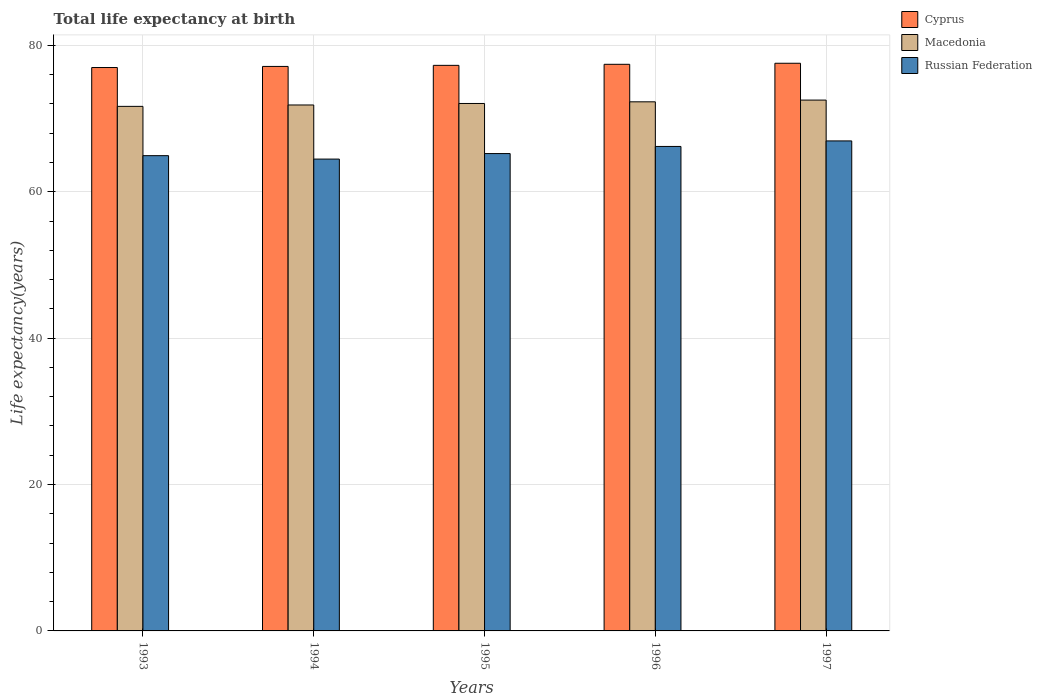How many different coloured bars are there?
Offer a very short reply. 3. Are the number of bars per tick equal to the number of legend labels?
Your answer should be very brief. Yes. Are the number of bars on each tick of the X-axis equal?
Offer a very short reply. Yes. What is the life expectancy at birth in in Russian Federation in 1996?
Make the answer very short. 66.19. Across all years, what is the maximum life expectancy at birth in in Russian Federation?
Give a very brief answer. 66.95. Across all years, what is the minimum life expectancy at birth in in Macedonia?
Give a very brief answer. 71.67. In which year was the life expectancy at birth in in Cyprus minimum?
Offer a terse response. 1993. What is the total life expectancy at birth in in Russian Federation in the graph?
Your answer should be compact. 327.77. What is the difference between the life expectancy at birth in in Russian Federation in 1994 and that in 1997?
Keep it short and to the point. -2.48. What is the difference between the life expectancy at birth in in Cyprus in 1993 and the life expectancy at birth in in Russian Federation in 1994?
Keep it short and to the point. 12.51. What is the average life expectancy at birth in in Macedonia per year?
Your answer should be compact. 72.08. In the year 1994, what is the difference between the life expectancy at birth in in Macedonia and life expectancy at birth in in Russian Federation?
Your response must be concise. 7.39. In how many years, is the life expectancy at birth in in Cyprus greater than 40 years?
Provide a short and direct response. 5. What is the ratio of the life expectancy at birth in in Macedonia in 1996 to that in 1997?
Your response must be concise. 1. Is the life expectancy at birth in in Russian Federation in 1993 less than that in 1997?
Provide a succinct answer. Yes. What is the difference between the highest and the second highest life expectancy at birth in in Russian Federation?
Keep it short and to the point. 0.76. What is the difference between the highest and the lowest life expectancy at birth in in Macedonia?
Offer a very short reply. 0.86. In how many years, is the life expectancy at birth in in Macedonia greater than the average life expectancy at birth in in Macedonia taken over all years?
Provide a succinct answer. 2. Is the sum of the life expectancy at birth in in Macedonia in 1995 and 1997 greater than the maximum life expectancy at birth in in Cyprus across all years?
Give a very brief answer. Yes. What does the 3rd bar from the left in 1993 represents?
Provide a short and direct response. Russian Federation. What does the 2nd bar from the right in 1997 represents?
Provide a short and direct response. Macedonia. Is it the case that in every year, the sum of the life expectancy at birth in in Cyprus and life expectancy at birth in in Russian Federation is greater than the life expectancy at birth in in Macedonia?
Ensure brevity in your answer.  Yes. How many bars are there?
Your answer should be compact. 15. Are all the bars in the graph horizontal?
Offer a very short reply. No. How many years are there in the graph?
Provide a succinct answer. 5. What is the difference between two consecutive major ticks on the Y-axis?
Offer a terse response. 20. Are the values on the major ticks of Y-axis written in scientific E-notation?
Offer a terse response. No. How are the legend labels stacked?
Provide a succinct answer. Vertical. What is the title of the graph?
Provide a short and direct response. Total life expectancy at birth. What is the label or title of the Y-axis?
Provide a succinct answer. Life expectancy(years). What is the Life expectancy(years) in Cyprus in 1993?
Offer a very short reply. 76.98. What is the Life expectancy(years) of Macedonia in 1993?
Provide a short and direct response. 71.67. What is the Life expectancy(years) of Russian Federation in 1993?
Provide a succinct answer. 64.94. What is the Life expectancy(years) of Cyprus in 1994?
Your answer should be compact. 77.13. What is the Life expectancy(years) of Macedonia in 1994?
Give a very brief answer. 71.86. What is the Life expectancy(years) of Russian Federation in 1994?
Your response must be concise. 64.47. What is the Life expectancy(years) in Cyprus in 1995?
Offer a very short reply. 77.27. What is the Life expectancy(years) of Macedonia in 1995?
Offer a very short reply. 72.07. What is the Life expectancy(years) in Russian Federation in 1995?
Make the answer very short. 65.22. What is the Life expectancy(years) of Cyprus in 1996?
Provide a short and direct response. 77.42. What is the Life expectancy(years) of Macedonia in 1996?
Give a very brief answer. 72.29. What is the Life expectancy(years) in Russian Federation in 1996?
Ensure brevity in your answer.  66.19. What is the Life expectancy(years) in Cyprus in 1997?
Offer a very short reply. 77.56. What is the Life expectancy(years) in Macedonia in 1997?
Your response must be concise. 72.53. What is the Life expectancy(years) in Russian Federation in 1997?
Your response must be concise. 66.95. Across all years, what is the maximum Life expectancy(years) in Cyprus?
Provide a short and direct response. 77.56. Across all years, what is the maximum Life expectancy(years) of Macedonia?
Offer a terse response. 72.53. Across all years, what is the maximum Life expectancy(years) of Russian Federation?
Make the answer very short. 66.95. Across all years, what is the minimum Life expectancy(years) in Cyprus?
Make the answer very short. 76.98. Across all years, what is the minimum Life expectancy(years) in Macedonia?
Offer a very short reply. 71.67. Across all years, what is the minimum Life expectancy(years) in Russian Federation?
Keep it short and to the point. 64.47. What is the total Life expectancy(years) in Cyprus in the graph?
Your answer should be compact. 386.36. What is the total Life expectancy(years) in Macedonia in the graph?
Your answer should be compact. 360.42. What is the total Life expectancy(years) in Russian Federation in the graph?
Ensure brevity in your answer.  327.77. What is the difference between the Life expectancy(years) of Cyprus in 1993 and that in 1994?
Keep it short and to the point. -0.15. What is the difference between the Life expectancy(years) of Macedonia in 1993 and that in 1994?
Offer a terse response. -0.19. What is the difference between the Life expectancy(years) of Russian Federation in 1993 and that in 1994?
Give a very brief answer. 0.47. What is the difference between the Life expectancy(years) of Cyprus in 1993 and that in 1995?
Offer a very short reply. -0.3. What is the difference between the Life expectancy(years) in Macedonia in 1993 and that in 1995?
Give a very brief answer. -0.4. What is the difference between the Life expectancy(years) in Russian Federation in 1993 and that in 1995?
Your answer should be very brief. -0.29. What is the difference between the Life expectancy(years) of Cyprus in 1993 and that in 1996?
Provide a short and direct response. -0.44. What is the difference between the Life expectancy(years) in Macedonia in 1993 and that in 1996?
Make the answer very short. -0.62. What is the difference between the Life expectancy(years) of Russian Federation in 1993 and that in 1996?
Provide a short and direct response. -1.26. What is the difference between the Life expectancy(years) of Cyprus in 1993 and that in 1997?
Give a very brief answer. -0.58. What is the difference between the Life expectancy(years) in Macedonia in 1993 and that in 1997?
Your response must be concise. -0.86. What is the difference between the Life expectancy(years) of Russian Federation in 1993 and that in 1997?
Offer a terse response. -2.01. What is the difference between the Life expectancy(years) of Cyprus in 1994 and that in 1995?
Give a very brief answer. -0.15. What is the difference between the Life expectancy(years) of Macedonia in 1994 and that in 1995?
Your answer should be very brief. -0.21. What is the difference between the Life expectancy(years) of Russian Federation in 1994 and that in 1995?
Your answer should be compact. -0.75. What is the difference between the Life expectancy(years) of Cyprus in 1994 and that in 1996?
Your answer should be compact. -0.29. What is the difference between the Life expectancy(years) of Macedonia in 1994 and that in 1996?
Your answer should be compact. -0.43. What is the difference between the Life expectancy(years) in Russian Federation in 1994 and that in 1996?
Provide a short and direct response. -1.73. What is the difference between the Life expectancy(years) in Cyprus in 1994 and that in 1997?
Provide a short and direct response. -0.43. What is the difference between the Life expectancy(years) of Macedonia in 1994 and that in 1997?
Your response must be concise. -0.67. What is the difference between the Life expectancy(years) of Russian Federation in 1994 and that in 1997?
Keep it short and to the point. -2.48. What is the difference between the Life expectancy(years) of Cyprus in 1995 and that in 1996?
Provide a short and direct response. -0.14. What is the difference between the Life expectancy(years) in Macedonia in 1995 and that in 1996?
Offer a terse response. -0.23. What is the difference between the Life expectancy(years) in Russian Federation in 1995 and that in 1996?
Keep it short and to the point. -0.97. What is the difference between the Life expectancy(years) of Cyprus in 1995 and that in 1997?
Offer a very short reply. -0.29. What is the difference between the Life expectancy(years) of Macedonia in 1995 and that in 1997?
Keep it short and to the point. -0.46. What is the difference between the Life expectancy(years) in Russian Federation in 1995 and that in 1997?
Your answer should be very brief. -1.73. What is the difference between the Life expectancy(years) of Cyprus in 1996 and that in 1997?
Offer a very short reply. -0.14. What is the difference between the Life expectancy(years) of Macedonia in 1996 and that in 1997?
Offer a very short reply. -0.24. What is the difference between the Life expectancy(years) of Russian Federation in 1996 and that in 1997?
Keep it short and to the point. -0.76. What is the difference between the Life expectancy(years) in Cyprus in 1993 and the Life expectancy(years) in Macedonia in 1994?
Provide a short and direct response. 5.12. What is the difference between the Life expectancy(years) in Cyprus in 1993 and the Life expectancy(years) in Russian Federation in 1994?
Your answer should be compact. 12.51. What is the difference between the Life expectancy(years) of Macedonia in 1993 and the Life expectancy(years) of Russian Federation in 1994?
Provide a succinct answer. 7.2. What is the difference between the Life expectancy(years) of Cyprus in 1993 and the Life expectancy(years) of Macedonia in 1995?
Keep it short and to the point. 4.91. What is the difference between the Life expectancy(years) of Cyprus in 1993 and the Life expectancy(years) of Russian Federation in 1995?
Provide a succinct answer. 11.76. What is the difference between the Life expectancy(years) in Macedonia in 1993 and the Life expectancy(years) in Russian Federation in 1995?
Offer a very short reply. 6.45. What is the difference between the Life expectancy(years) of Cyprus in 1993 and the Life expectancy(years) of Macedonia in 1996?
Your response must be concise. 4.69. What is the difference between the Life expectancy(years) in Cyprus in 1993 and the Life expectancy(years) in Russian Federation in 1996?
Your answer should be very brief. 10.78. What is the difference between the Life expectancy(years) of Macedonia in 1993 and the Life expectancy(years) of Russian Federation in 1996?
Your response must be concise. 5.48. What is the difference between the Life expectancy(years) of Cyprus in 1993 and the Life expectancy(years) of Macedonia in 1997?
Provide a succinct answer. 4.45. What is the difference between the Life expectancy(years) of Cyprus in 1993 and the Life expectancy(years) of Russian Federation in 1997?
Ensure brevity in your answer.  10.03. What is the difference between the Life expectancy(years) of Macedonia in 1993 and the Life expectancy(years) of Russian Federation in 1997?
Keep it short and to the point. 4.72. What is the difference between the Life expectancy(years) of Cyprus in 1994 and the Life expectancy(years) of Macedonia in 1995?
Your response must be concise. 5.06. What is the difference between the Life expectancy(years) of Cyprus in 1994 and the Life expectancy(years) of Russian Federation in 1995?
Your answer should be very brief. 11.91. What is the difference between the Life expectancy(years) in Macedonia in 1994 and the Life expectancy(years) in Russian Federation in 1995?
Your response must be concise. 6.64. What is the difference between the Life expectancy(years) of Cyprus in 1994 and the Life expectancy(years) of Macedonia in 1996?
Ensure brevity in your answer.  4.84. What is the difference between the Life expectancy(years) in Cyprus in 1994 and the Life expectancy(years) in Russian Federation in 1996?
Keep it short and to the point. 10.93. What is the difference between the Life expectancy(years) in Macedonia in 1994 and the Life expectancy(years) in Russian Federation in 1996?
Provide a short and direct response. 5.67. What is the difference between the Life expectancy(years) in Cyprus in 1994 and the Life expectancy(years) in Macedonia in 1997?
Your answer should be compact. 4.6. What is the difference between the Life expectancy(years) in Cyprus in 1994 and the Life expectancy(years) in Russian Federation in 1997?
Your answer should be compact. 10.18. What is the difference between the Life expectancy(years) of Macedonia in 1994 and the Life expectancy(years) of Russian Federation in 1997?
Your answer should be compact. 4.91. What is the difference between the Life expectancy(years) in Cyprus in 1995 and the Life expectancy(years) in Macedonia in 1996?
Your answer should be very brief. 4.98. What is the difference between the Life expectancy(years) in Cyprus in 1995 and the Life expectancy(years) in Russian Federation in 1996?
Offer a very short reply. 11.08. What is the difference between the Life expectancy(years) in Macedonia in 1995 and the Life expectancy(years) in Russian Federation in 1996?
Provide a succinct answer. 5.87. What is the difference between the Life expectancy(years) of Cyprus in 1995 and the Life expectancy(years) of Macedonia in 1997?
Make the answer very short. 4.75. What is the difference between the Life expectancy(years) of Cyprus in 1995 and the Life expectancy(years) of Russian Federation in 1997?
Your answer should be very brief. 10.32. What is the difference between the Life expectancy(years) in Macedonia in 1995 and the Life expectancy(years) in Russian Federation in 1997?
Make the answer very short. 5.12. What is the difference between the Life expectancy(years) of Cyprus in 1996 and the Life expectancy(years) of Macedonia in 1997?
Your response must be concise. 4.89. What is the difference between the Life expectancy(years) in Cyprus in 1996 and the Life expectancy(years) in Russian Federation in 1997?
Your answer should be very brief. 10.47. What is the difference between the Life expectancy(years) of Macedonia in 1996 and the Life expectancy(years) of Russian Federation in 1997?
Your answer should be compact. 5.34. What is the average Life expectancy(years) of Cyprus per year?
Offer a terse response. 77.27. What is the average Life expectancy(years) of Macedonia per year?
Ensure brevity in your answer.  72.08. What is the average Life expectancy(years) in Russian Federation per year?
Provide a succinct answer. 65.55. In the year 1993, what is the difference between the Life expectancy(years) in Cyprus and Life expectancy(years) in Macedonia?
Provide a short and direct response. 5.31. In the year 1993, what is the difference between the Life expectancy(years) in Cyprus and Life expectancy(years) in Russian Federation?
Give a very brief answer. 12.04. In the year 1993, what is the difference between the Life expectancy(years) in Macedonia and Life expectancy(years) in Russian Federation?
Ensure brevity in your answer.  6.74. In the year 1994, what is the difference between the Life expectancy(years) in Cyprus and Life expectancy(years) in Macedonia?
Offer a terse response. 5.27. In the year 1994, what is the difference between the Life expectancy(years) in Cyprus and Life expectancy(years) in Russian Federation?
Ensure brevity in your answer.  12.66. In the year 1994, what is the difference between the Life expectancy(years) in Macedonia and Life expectancy(years) in Russian Federation?
Ensure brevity in your answer.  7.39. In the year 1995, what is the difference between the Life expectancy(years) in Cyprus and Life expectancy(years) in Macedonia?
Give a very brief answer. 5.21. In the year 1995, what is the difference between the Life expectancy(years) in Cyprus and Life expectancy(years) in Russian Federation?
Make the answer very short. 12.05. In the year 1995, what is the difference between the Life expectancy(years) in Macedonia and Life expectancy(years) in Russian Federation?
Provide a short and direct response. 6.85. In the year 1996, what is the difference between the Life expectancy(years) of Cyprus and Life expectancy(years) of Macedonia?
Make the answer very short. 5.13. In the year 1996, what is the difference between the Life expectancy(years) of Cyprus and Life expectancy(years) of Russian Federation?
Offer a terse response. 11.22. In the year 1996, what is the difference between the Life expectancy(years) of Macedonia and Life expectancy(years) of Russian Federation?
Ensure brevity in your answer.  6.1. In the year 1997, what is the difference between the Life expectancy(years) of Cyprus and Life expectancy(years) of Macedonia?
Offer a very short reply. 5.03. In the year 1997, what is the difference between the Life expectancy(years) in Cyprus and Life expectancy(years) in Russian Federation?
Make the answer very short. 10.61. In the year 1997, what is the difference between the Life expectancy(years) in Macedonia and Life expectancy(years) in Russian Federation?
Provide a short and direct response. 5.58. What is the ratio of the Life expectancy(years) in Russian Federation in 1993 to that in 1994?
Your answer should be very brief. 1.01. What is the ratio of the Life expectancy(years) of Cyprus in 1993 to that in 1995?
Offer a very short reply. 1. What is the ratio of the Life expectancy(years) in Macedonia in 1993 to that in 1995?
Make the answer very short. 0.99. What is the ratio of the Life expectancy(years) in Cyprus in 1993 to that in 1996?
Provide a short and direct response. 0.99. What is the ratio of the Life expectancy(years) in Macedonia in 1993 to that in 1996?
Your answer should be very brief. 0.99. What is the ratio of the Life expectancy(years) of Cyprus in 1993 to that in 1997?
Make the answer very short. 0.99. What is the ratio of the Life expectancy(years) of Macedonia in 1993 to that in 1997?
Provide a short and direct response. 0.99. What is the ratio of the Life expectancy(years) of Russian Federation in 1993 to that in 1997?
Provide a short and direct response. 0.97. What is the ratio of the Life expectancy(years) of Russian Federation in 1994 to that in 1995?
Offer a very short reply. 0.99. What is the ratio of the Life expectancy(years) in Cyprus in 1994 to that in 1996?
Provide a short and direct response. 1. What is the ratio of the Life expectancy(years) of Macedonia in 1994 to that in 1996?
Offer a terse response. 0.99. What is the ratio of the Life expectancy(years) of Russian Federation in 1994 to that in 1996?
Offer a terse response. 0.97. What is the ratio of the Life expectancy(years) in Cyprus in 1994 to that in 1997?
Give a very brief answer. 0.99. What is the ratio of the Life expectancy(years) in Russian Federation in 1994 to that in 1997?
Make the answer very short. 0.96. What is the ratio of the Life expectancy(years) in Russian Federation in 1995 to that in 1996?
Provide a short and direct response. 0.99. What is the ratio of the Life expectancy(years) of Cyprus in 1995 to that in 1997?
Provide a succinct answer. 1. What is the ratio of the Life expectancy(years) in Russian Federation in 1995 to that in 1997?
Offer a very short reply. 0.97. What is the ratio of the Life expectancy(years) of Russian Federation in 1996 to that in 1997?
Keep it short and to the point. 0.99. What is the difference between the highest and the second highest Life expectancy(years) in Cyprus?
Keep it short and to the point. 0.14. What is the difference between the highest and the second highest Life expectancy(years) of Macedonia?
Offer a very short reply. 0.24. What is the difference between the highest and the second highest Life expectancy(years) in Russian Federation?
Provide a succinct answer. 0.76. What is the difference between the highest and the lowest Life expectancy(years) in Cyprus?
Make the answer very short. 0.58. What is the difference between the highest and the lowest Life expectancy(years) in Macedonia?
Ensure brevity in your answer.  0.86. What is the difference between the highest and the lowest Life expectancy(years) in Russian Federation?
Make the answer very short. 2.48. 